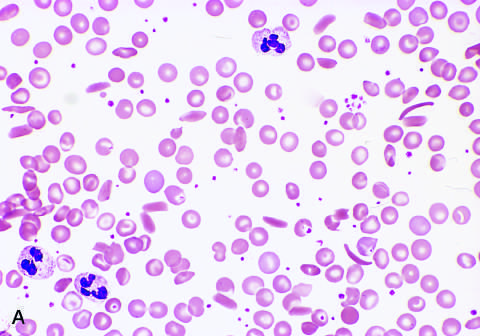what shows sickle cells, anisocytosis, poikilocytosis, and target cells?
Answer the question using a single word or phrase. Low magnification 